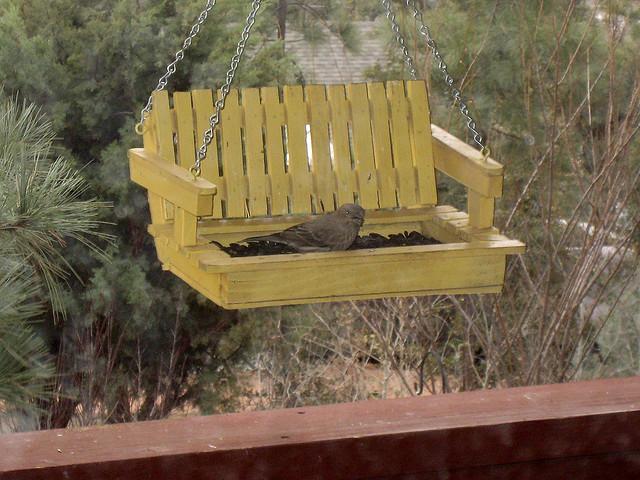How many chains are holding up the bench?
Give a very brief answer. 4. How many birds are on the bird house?
Give a very brief answer. 1. 